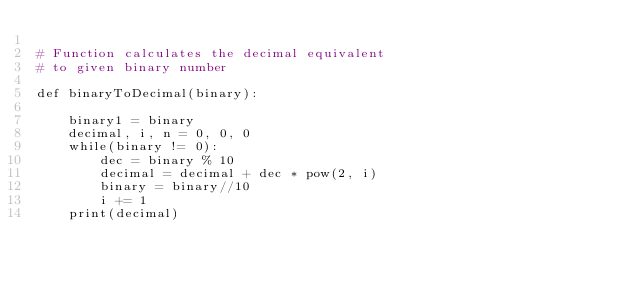Convert code to text. <code><loc_0><loc_0><loc_500><loc_500><_Python_>
# Function calculates the decimal equivalent  
# to given binary number 
  
def binaryToDecimal(binary): 
      
    binary1 = binary 
    decimal, i, n = 0, 0, 0
    while(binary != 0): 
        dec = binary % 10
        decimal = decimal + dec * pow(2, i) 
        binary = binary//10
        i += 1
    print(decimal)   </code> 